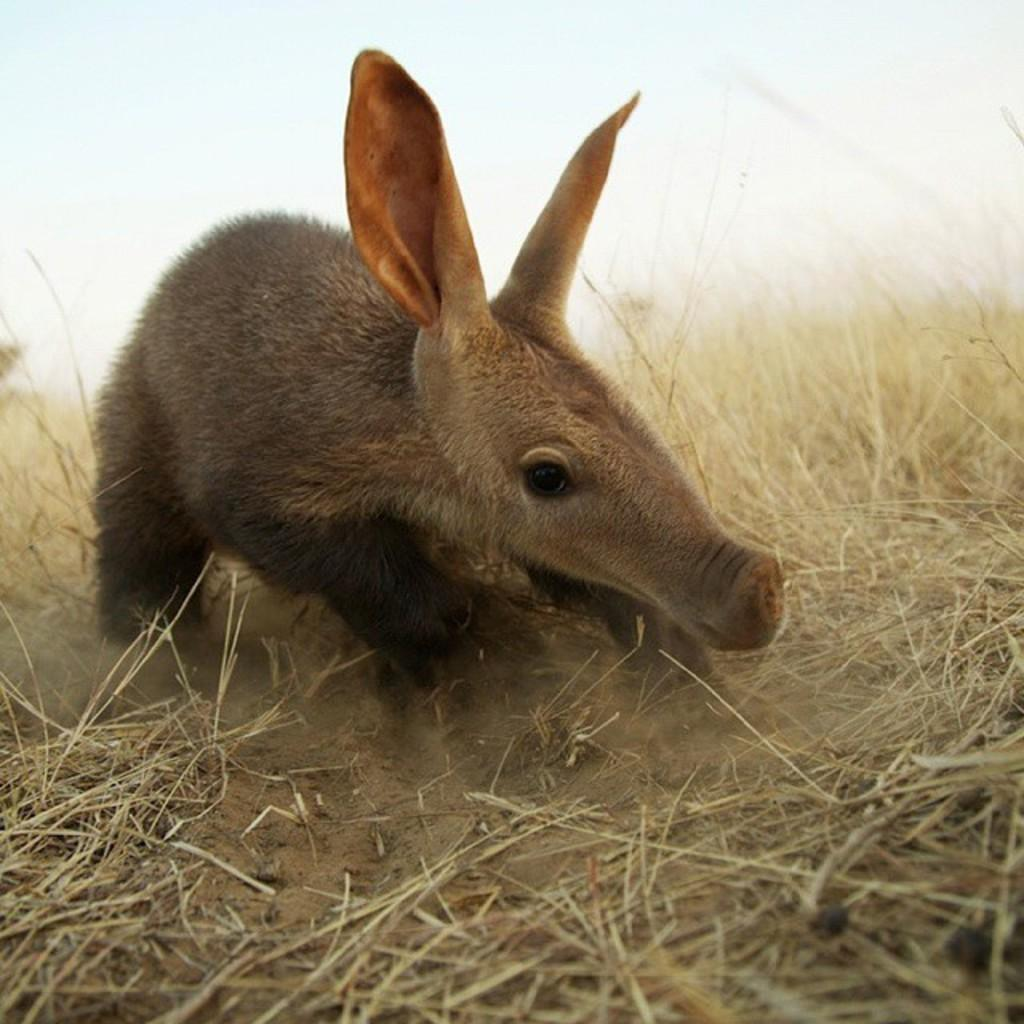What type of creature is in the image? There is an animal in the image. Where is the animal located? The animal is on a grassland. What can be observed about the background of the image? The background of the image is blurred. What is the purpose of the insect in the image? There is no insect present in the image, so it is not possible to determine its purpose. 